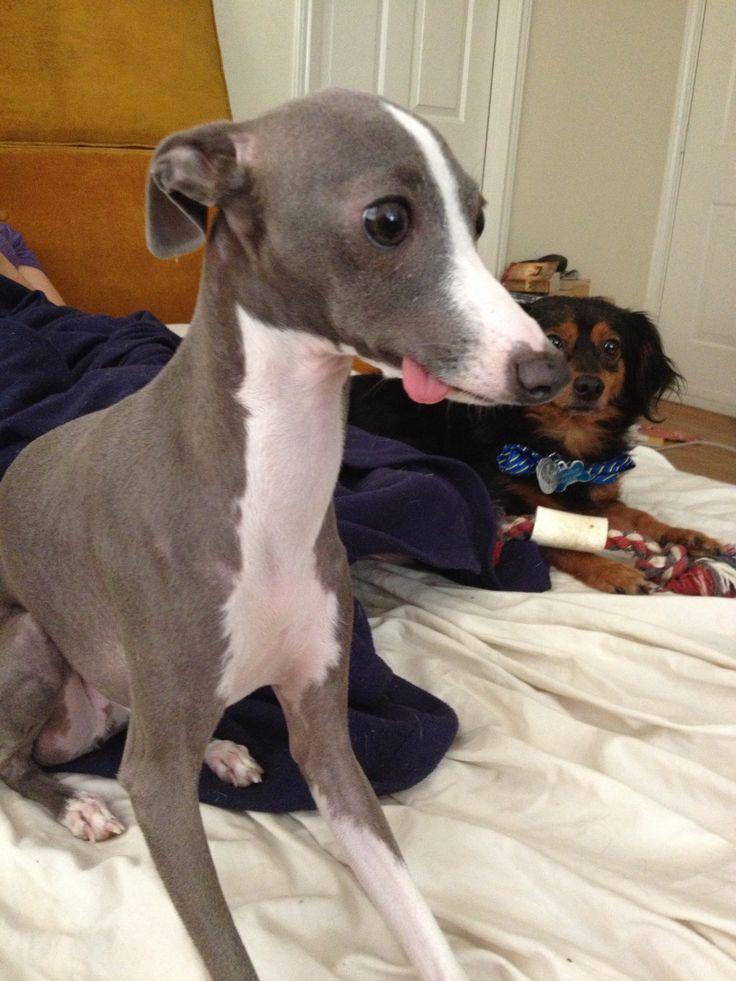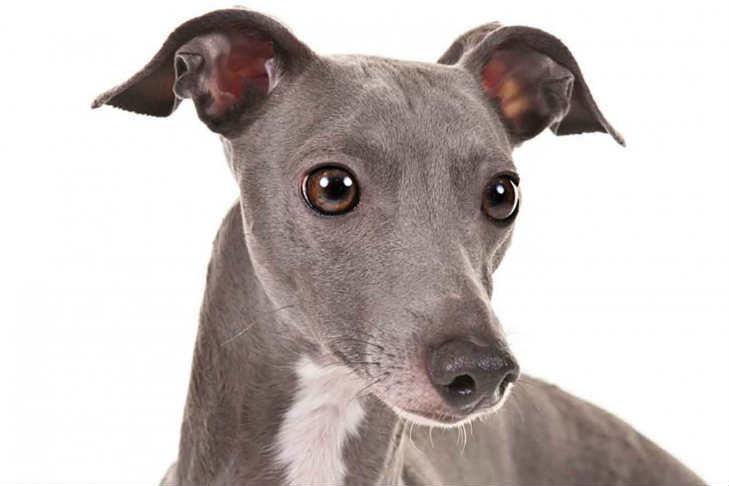The first image is the image on the left, the second image is the image on the right. Considering the images on both sides, is "A dog is sitting on a cloth." valid? Answer yes or no. Yes. 